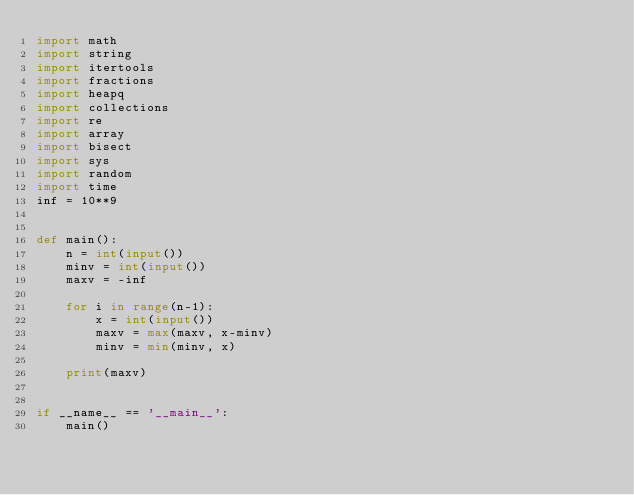<code> <loc_0><loc_0><loc_500><loc_500><_Python_>import math
import string
import itertools
import fractions
import heapq
import collections
import re
import array
import bisect
import sys
import random
import time
inf = 10**9


def main():
    n = int(input())
    minv = int(input())
    maxv = -inf

    for i in range(n-1):
        x = int(input())
        maxv = max(maxv, x-minv)
        minv = min(minv, x)

    print(maxv)


if __name__ == '__main__':
    main()

</code> 